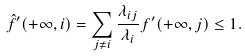<formula> <loc_0><loc_0><loc_500><loc_500>\hat { f } ^ { \prime } ( + \infty , i ) = \sum _ { j \neq i } \frac { \lambda _ { i j } } { { \lambda } _ { i } } f ^ { \prime } ( + \infty , j ) \leq 1 .</formula> 